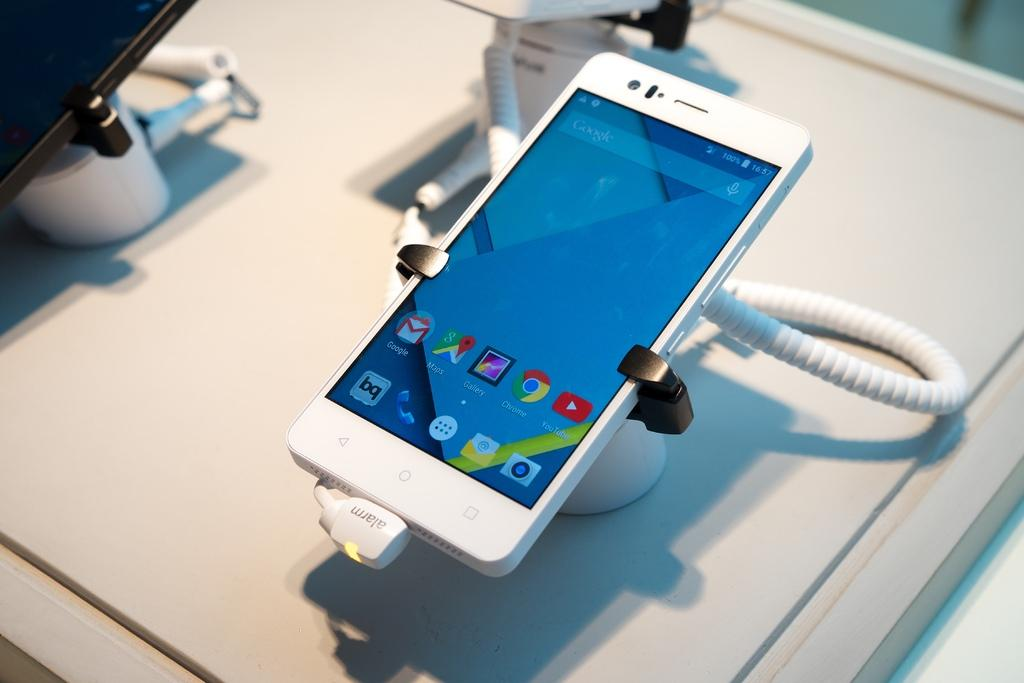<image>
Offer a succinct explanation of the picture presented. a phone with a YouTube icon on it 